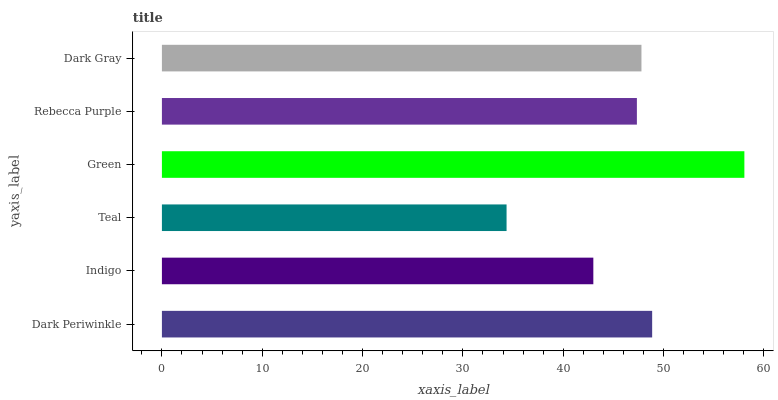Is Teal the minimum?
Answer yes or no. Yes. Is Green the maximum?
Answer yes or no. Yes. Is Indigo the minimum?
Answer yes or no. No. Is Indigo the maximum?
Answer yes or no. No. Is Dark Periwinkle greater than Indigo?
Answer yes or no. Yes. Is Indigo less than Dark Periwinkle?
Answer yes or no. Yes. Is Indigo greater than Dark Periwinkle?
Answer yes or no. No. Is Dark Periwinkle less than Indigo?
Answer yes or no. No. Is Dark Gray the high median?
Answer yes or no. Yes. Is Rebecca Purple the low median?
Answer yes or no. Yes. Is Indigo the high median?
Answer yes or no. No. Is Dark Periwinkle the low median?
Answer yes or no. No. 